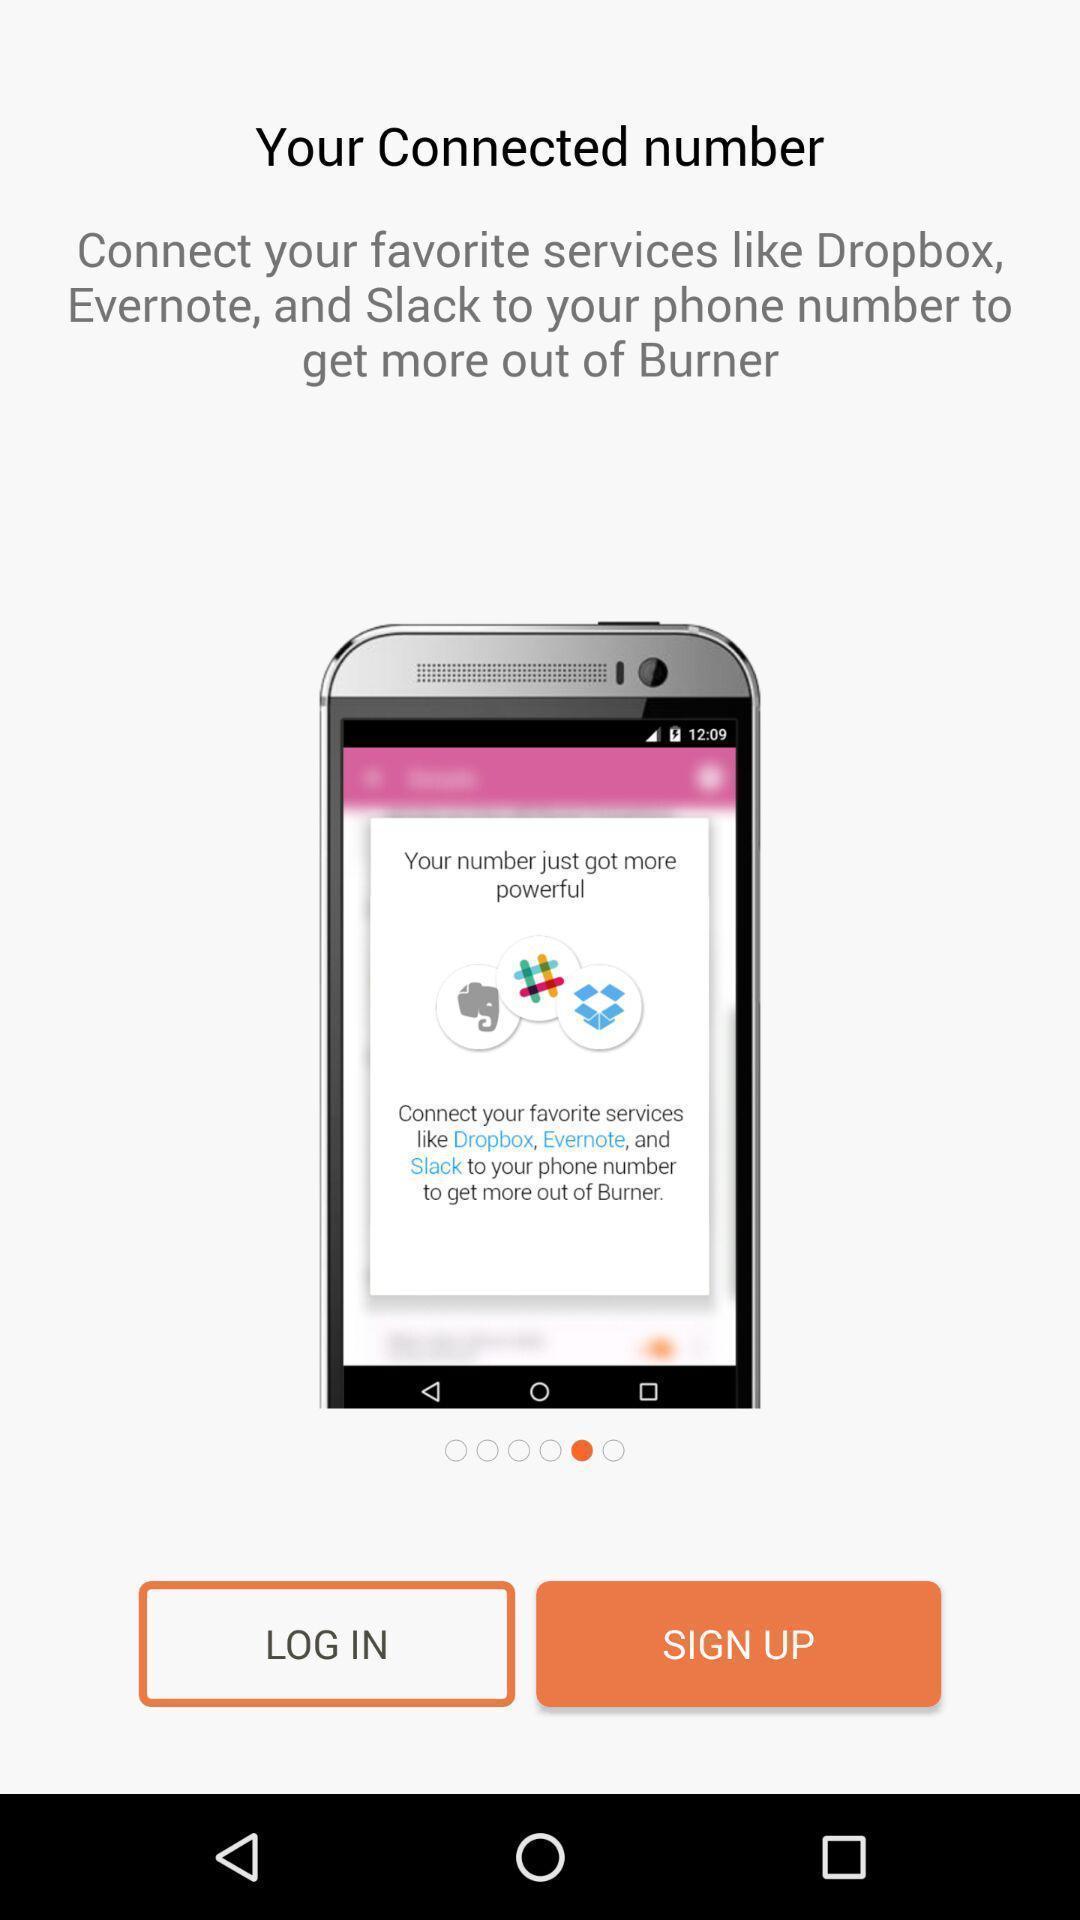Give me a narrative description of this picture. Welcome and log-in page for an application. 